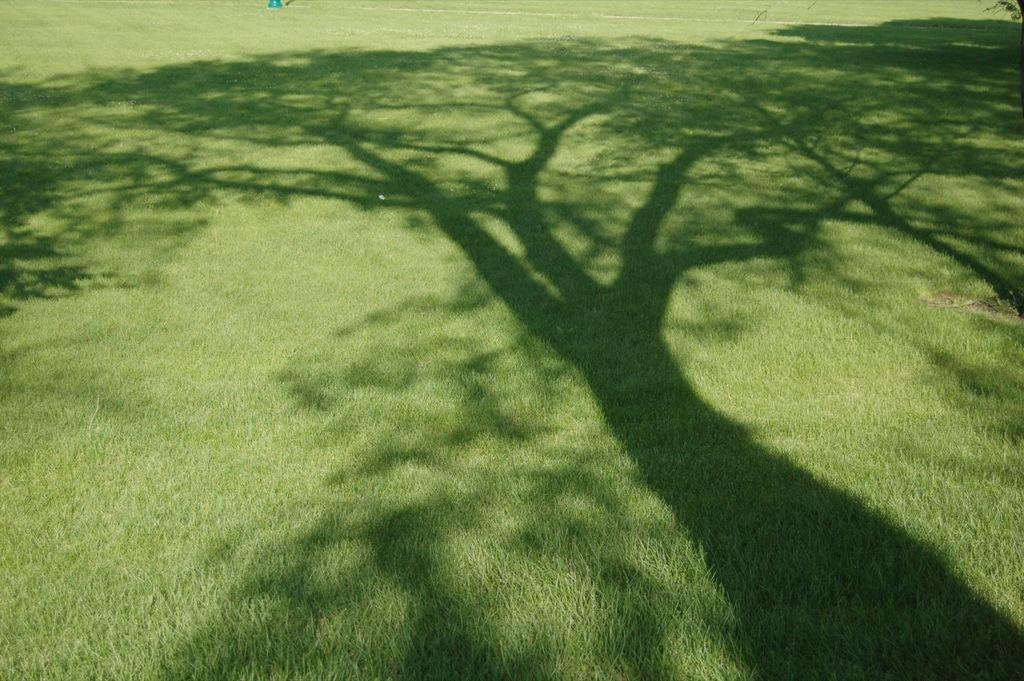What is the main feature of the image? The main feature of the image is the shadow of a tree. Where is the shadow located? The shadow is on the grass. How many women are singing a song in the image? There are no women or singing in the image; it only features the shadow of a tree on the grass. 